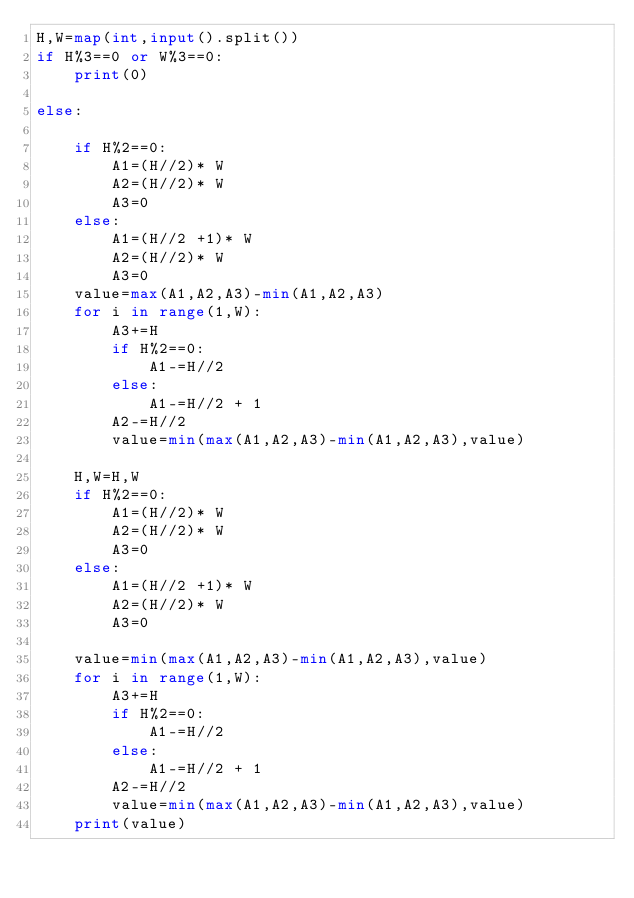Convert code to text. <code><loc_0><loc_0><loc_500><loc_500><_Python_>H,W=map(int,input().split())
if H%3==0 or W%3==0:
    print(0)

else:

    if H%2==0:
        A1=(H//2)* W
        A2=(H//2)* W
        A3=0
    else:
        A1=(H//2 +1)* W
        A2=(H//2)* W
        A3=0
    value=max(A1,A2,A3)-min(A1,A2,A3)
    for i in range(1,W):
        A3+=H
        if H%2==0:
            A1-=H//2
        else:
            A1-=H//2 + 1
        A2-=H//2
        value=min(max(A1,A2,A3)-min(A1,A2,A3),value)

    H,W=H,W
    if H%2==0:
        A1=(H//2)* W
        A2=(H//2)* W
        A3=0
    else:
        A1=(H//2 +1)* W
        A2=(H//2)* W
        A3=0

    value=min(max(A1,A2,A3)-min(A1,A2,A3),value)
    for i in range(1,W):
        A3+=H
        if H%2==0:
            A1-=H//2
        else:
            A1-=H//2 + 1
        A2-=H//2
        value=min(max(A1,A2,A3)-min(A1,A2,A3),value)
    print(value)
</code> 